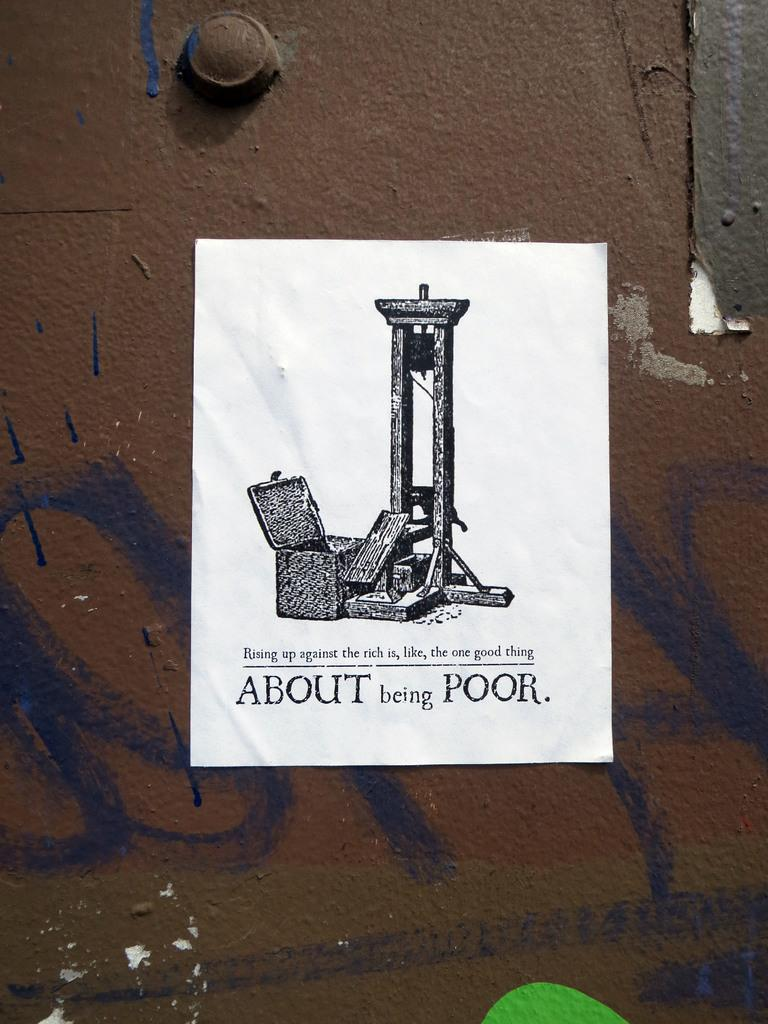<image>
Relay a brief, clear account of the picture shown. Paper showing a box and the phrase "About being Poor" on the bottom. 